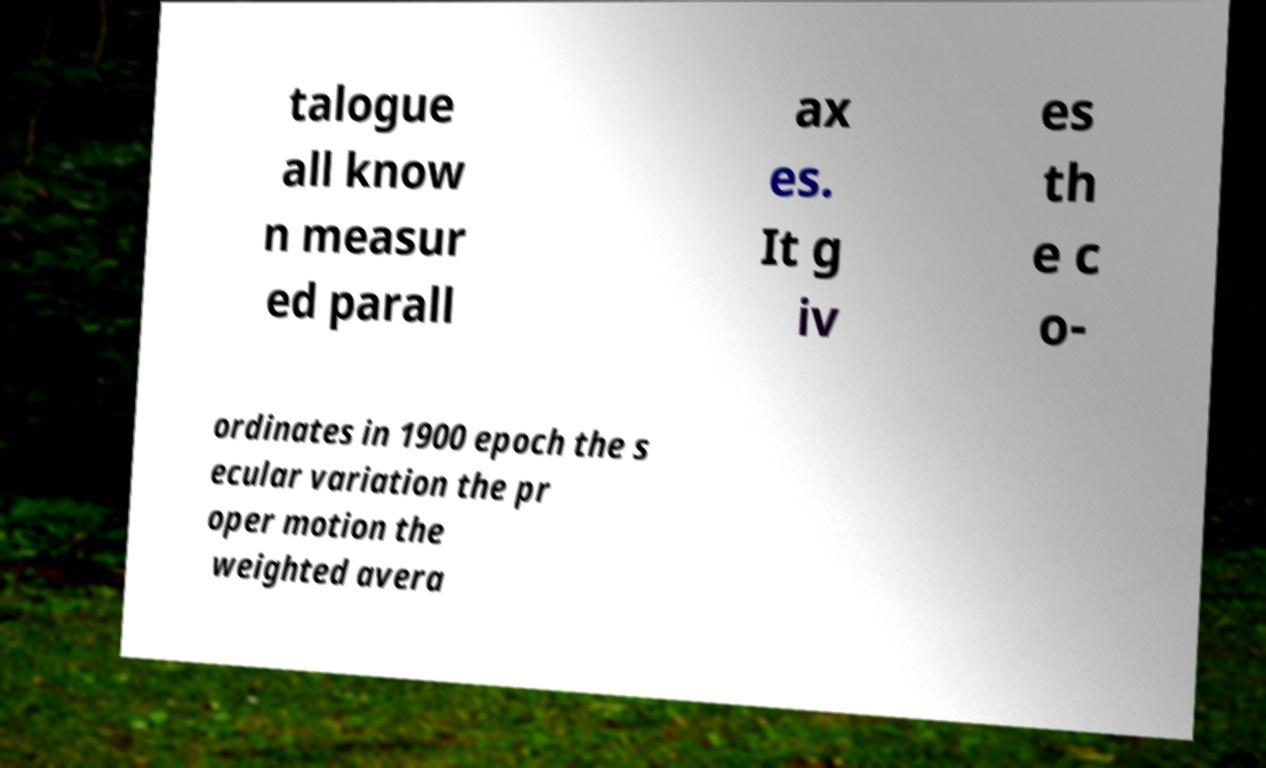For documentation purposes, I need the text within this image transcribed. Could you provide that? talogue all know n measur ed parall ax es. It g iv es th e c o- ordinates in 1900 epoch the s ecular variation the pr oper motion the weighted avera 